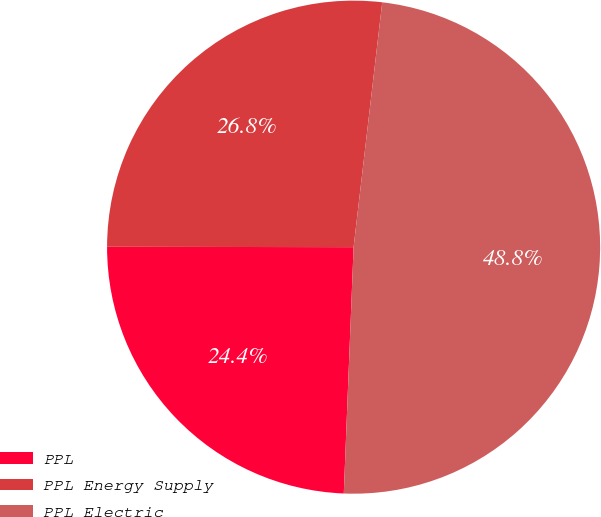<chart> <loc_0><loc_0><loc_500><loc_500><pie_chart><fcel>PPL<fcel>PPL Energy Supply<fcel>PPL Electric<nl><fcel>24.39%<fcel>26.83%<fcel>48.78%<nl></chart> 